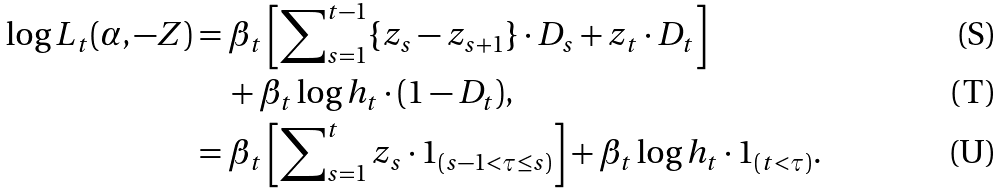<formula> <loc_0><loc_0><loc_500><loc_500>\log L _ { t } ( \alpha , - Z ) & = \beta _ { t } \left [ \sum \nolimits _ { s = 1 } ^ { t - 1 } \{ z _ { s } - z _ { s + 1 } \} \cdot D _ { s } + z _ { t } \cdot D _ { t } \right ] \\ & \quad + \beta _ { t } \log h _ { t } \cdot ( 1 - D _ { t } ) , \\ & = \beta _ { t } \left [ \sum \nolimits _ { s = 1 } ^ { t } z _ { s } \cdot 1 _ { ( s - 1 < \tau \leq s ) } \right ] + \beta _ { t } \log h _ { t } \cdot 1 _ { ( t < \tau ) } .</formula> 